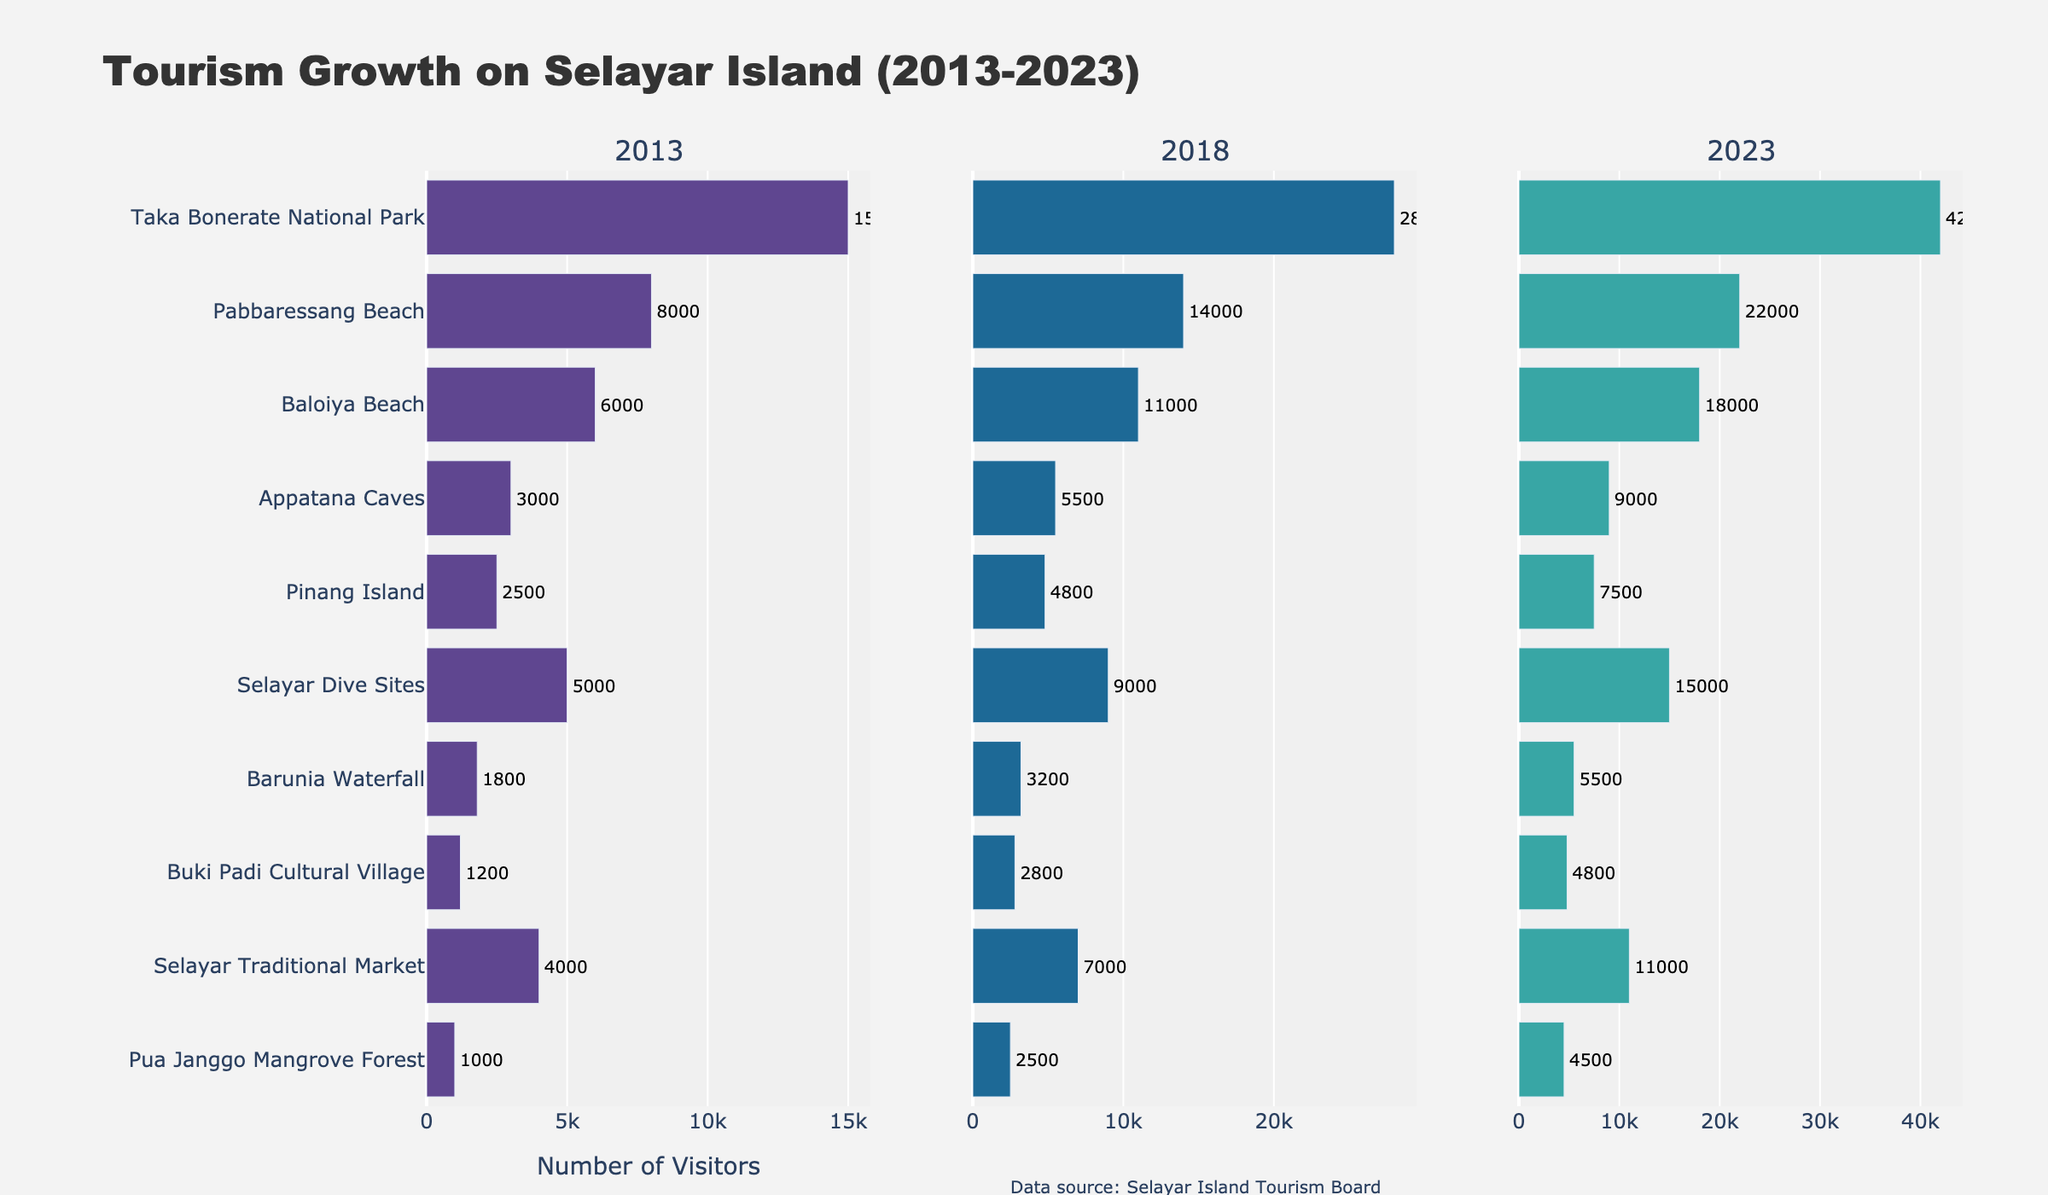What is the total number of visitors in 2023 for all attractions? Sum the visitors for all attractions in 2023: 42000 (Taka Bonerate) + 22000 (Pabbaressang Beach) + 18000 (Baloiya Beach) + 9000 (Appatana Caves) + 7500 (Pinang Island) + 15000 (Selayar Dive Sites) + 5500 (Barunia Waterfall) + 4800 (Buki Padi Cultural Village) + 11000 (Selayar Traditional Market) + 4500 (Pua Janggo Mangrove Forest) = 139800
Answer: 139800 Which attraction had the most visitors in 2013 and how many were there? Look at the bar corresponding to 2013, and identify the highest bar, which is Taka Bonerate National Park with 15000 visitors.
Answer: Taka Bonerate National Park, 15000 What is the growth in visitors from 2013 to 2023 for Pabbaressang Beach? Subtract the number of visitors in 2013 from the number in 2023: 22000 - 8000 = 14000
Answer: 14000 Which had more visitors in 2018, Baloiya Beach or Pinang Island? Compare the bars of Baloiya Beach and Pinang Island for the year 2018. Baloiya Beach had 11000 visitors and Pinang Island had 4800 visitors, so Baloiya Beach had more.
Answer: Baloiya Beach How many total visitors were there for Appatana Caves and Barunia Waterfall combined in 2023? Add the number of visitors for both attractions in 2023: 9000 (Appatana Caves) + 5500 (Barunia Waterfall) = 14500
Answer: 14500 Which year had the highest number of visitors for Selayar Traditional Market and what was the number? Check the bars for Selayar Traditional Market across the years and find that the bar for 2023 is the tallest with 11000 visitors.
Answer: 2023, 11000 What is the difference in the number of visitors between Taka Bonerate National Park and Selayar Dive Sites in 2023? Subtract the number of visitors to Selayar Dive Sites from Taka Bonerate National Park in 2023: 42000 - 15000 = 27000
Answer: 27000 Which attraction had the least growth from 2013 to 2023? Calculate the growth for each attraction by subtracting the 2013 numbers from the 2023 numbers and find the smallest difference: Pua Janggo Mangrove Forest had the least growth of 3500 (4500 - 1000).
Answer: Pua Janggo Mangrove Forest What is the average number of visitors in 2023 for Pinang Island, Selayar Dive Sites, and Buki Padi Cultural Village? Sum the visitors for the three attractions and divide by three: (7500 + 15000 + 4800) / 3 = 9100
Answer: 9100 Which attraction experienced the greatest relative growth from 2013 to 2023? Calculate relative growth percentage for each attraction: [(2023 value - 2013 value) / 2013 value] * 100. The highest percentage is for Buki Padi Cultural Village: [(4800 - 1200) / 1200] * 100 = 300%.
Answer: Buki Padi Cultural Village 